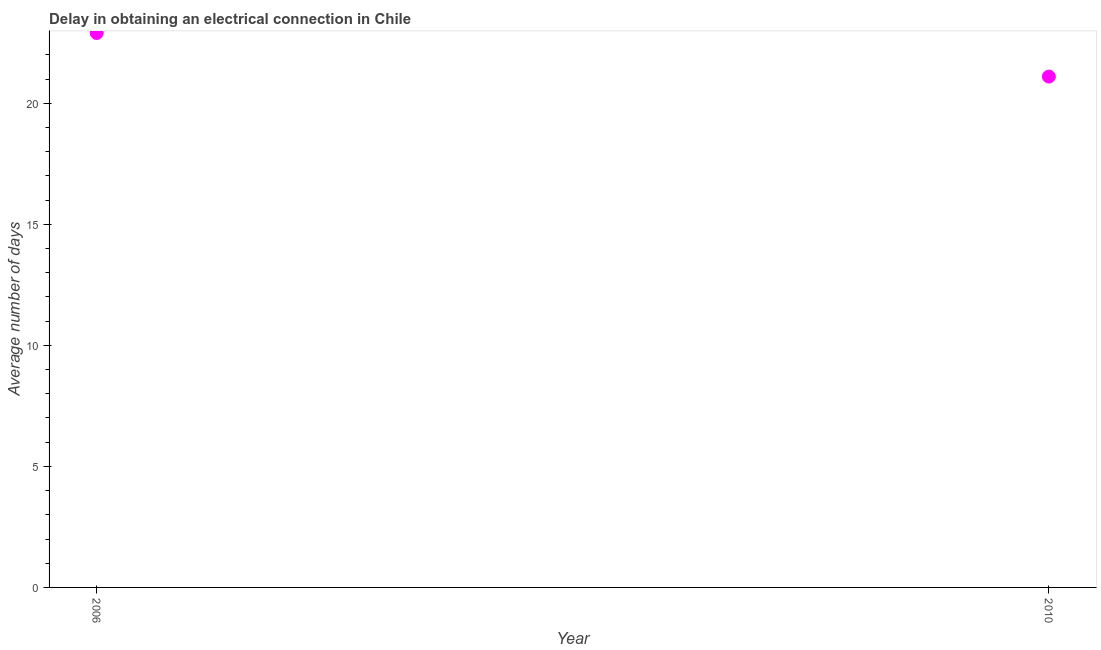What is the dalay in electrical connection in 2010?
Give a very brief answer. 21.1. Across all years, what is the maximum dalay in electrical connection?
Give a very brief answer. 22.9. Across all years, what is the minimum dalay in electrical connection?
Provide a succinct answer. 21.1. In which year was the dalay in electrical connection minimum?
Give a very brief answer. 2010. What is the difference between the dalay in electrical connection in 2006 and 2010?
Your answer should be compact. 1.8. What is the median dalay in electrical connection?
Offer a very short reply. 22. Do a majority of the years between 2006 and 2010 (inclusive) have dalay in electrical connection greater than 6 days?
Your response must be concise. Yes. What is the ratio of the dalay in electrical connection in 2006 to that in 2010?
Your response must be concise. 1.09. What is the title of the graph?
Keep it short and to the point. Delay in obtaining an electrical connection in Chile. What is the label or title of the X-axis?
Make the answer very short. Year. What is the label or title of the Y-axis?
Offer a very short reply. Average number of days. What is the Average number of days in 2006?
Offer a very short reply. 22.9. What is the Average number of days in 2010?
Give a very brief answer. 21.1. What is the ratio of the Average number of days in 2006 to that in 2010?
Your answer should be compact. 1.08. 